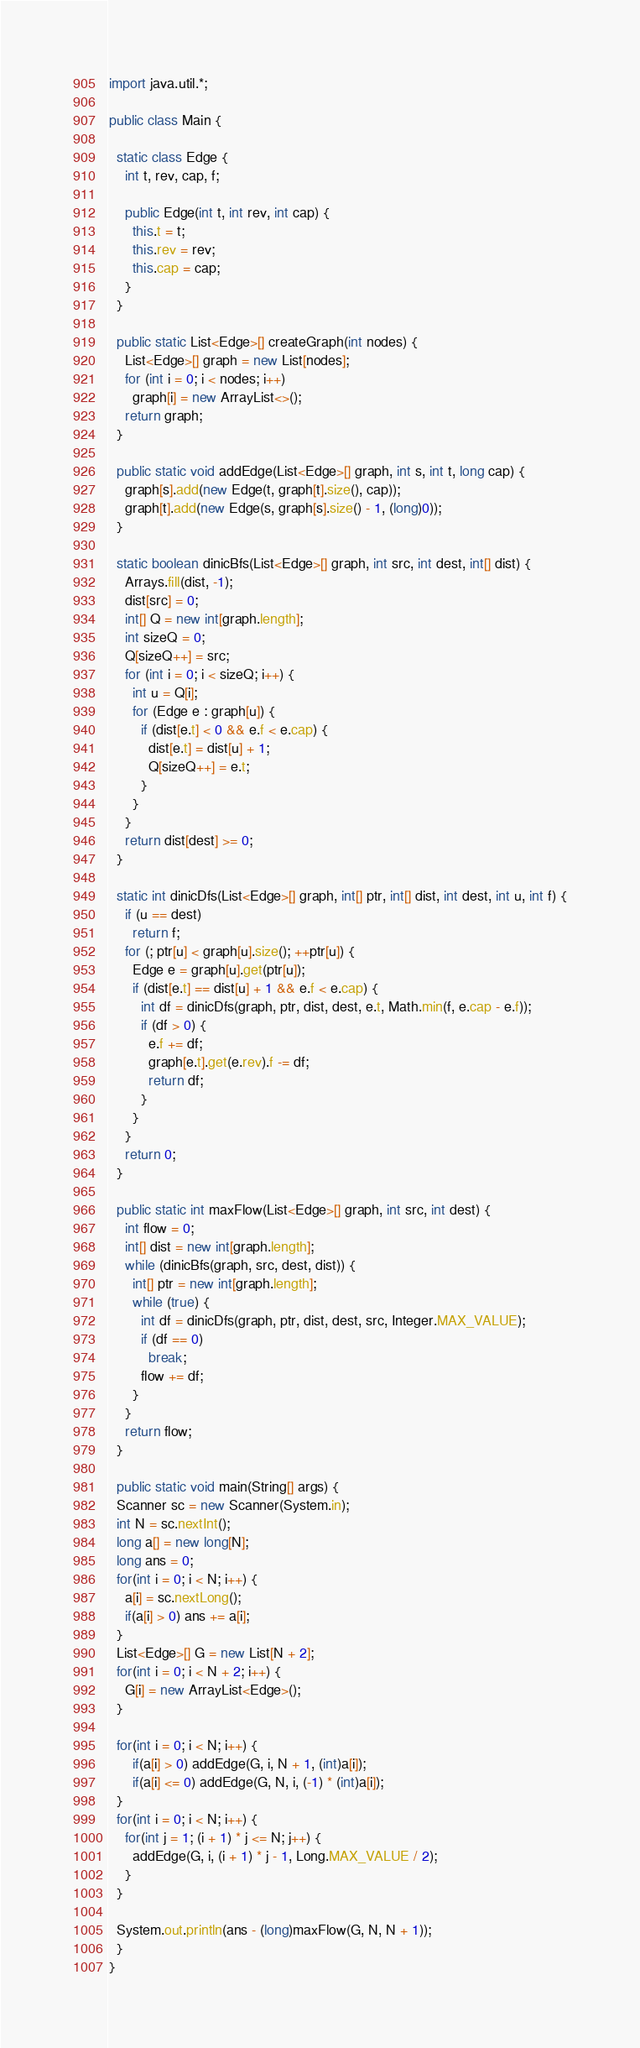<code> <loc_0><loc_0><loc_500><loc_500><_Java_>import java.util.*;

public class Main {

  static class Edge {
    int t, rev, cap, f;

    public Edge(int t, int rev, int cap) {
      this.t = t;
      this.rev = rev;
      this.cap = cap;
    }
  }

  public static List<Edge>[] createGraph(int nodes) {
    List<Edge>[] graph = new List[nodes];
    for (int i = 0; i < nodes; i++)
      graph[i] = new ArrayList<>();
    return graph;
  }

  public static void addEdge(List<Edge>[] graph, int s, int t, long cap) {
    graph[s].add(new Edge(t, graph[t].size(), cap));
    graph[t].add(new Edge(s, graph[s].size() - 1, (long)0));
  }

  static boolean dinicBfs(List<Edge>[] graph, int src, int dest, int[] dist) {
    Arrays.fill(dist, -1);
    dist[src] = 0;
    int[] Q = new int[graph.length];
    int sizeQ = 0;
    Q[sizeQ++] = src;
    for (int i = 0; i < sizeQ; i++) {
      int u = Q[i];
      for (Edge e : graph[u]) {
        if (dist[e.t] < 0 && e.f < e.cap) {
          dist[e.t] = dist[u] + 1;
          Q[sizeQ++] = e.t;
        }
      }
    }
    return dist[dest] >= 0;
  }

  static int dinicDfs(List<Edge>[] graph, int[] ptr, int[] dist, int dest, int u, int f) {
    if (u == dest)
      return f;
    for (; ptr[u] < graph[u].size(); ++ptr[u]) {
      Edge e = graph[u].get(ptr[u]);
      if (dist[e.t] == dist[u] + 1 && e.f < e.cap) {
        int df = dinicDfs(graph, ptr, dist, dest, e.t, Math.min(f, e.cap - e.f));
        if (df > 0) {
          e.f += df;
          graph[e.t].get(e.rev).f -= df;
          return df;
        }
      }
    }
    return 0;
  }

  public static int maxFlow(List<Edge>[] graph, int src, int dest) {
    int flow = 0;
    int[] dist = new int[graph.length];
    while (dinicBfs(graph, src, dest, dist)) {
      int[] ptr = new int[graph.length];
      while (true) {
        int df = dinicDfs(graph, ptr, dist, dest, src, Integer.MAX_VALUE);
        if (df == 0)
          break;
        flow += df;
      }
    }
    return flow;
  }

  public static void main(String[] args) {
  Scanner sc = new Scanner(System.in);
  int N = sc.nextInt();
  long a[] = new long[N];
  long ans = 0;
  for(int i = 0; i < N; i++) {
    a[i] = sc.nextLong();
    if(a[i] > 0) ans += a[i];
  }
  List<Edge>[] G = new List[N + 2];
  for(int i = 0; i < N + 2; i++) {
    G[i] = new ArrayList<Edge>();
  }

  for(int i = 0; i < N; i++) {
      if(a[i] > 0) addEdge(G, i, N + 1, (int)a[i]);
      if(a[i] <= 0) addEdge(G, N, i, (-1) * (int)a[i]);
  }
  for(int i = 0; i < N; i++) {
    for(int j = 1; (i + 1) * j <= N; j++) {
      addEdge(G, i, (i + 1) * j - 1, Long.MAX_VALUE / 2);
    }
  }

  System.out.println(ans - (long)maxFlow(G, N, N + 1));
  }
}</code> 